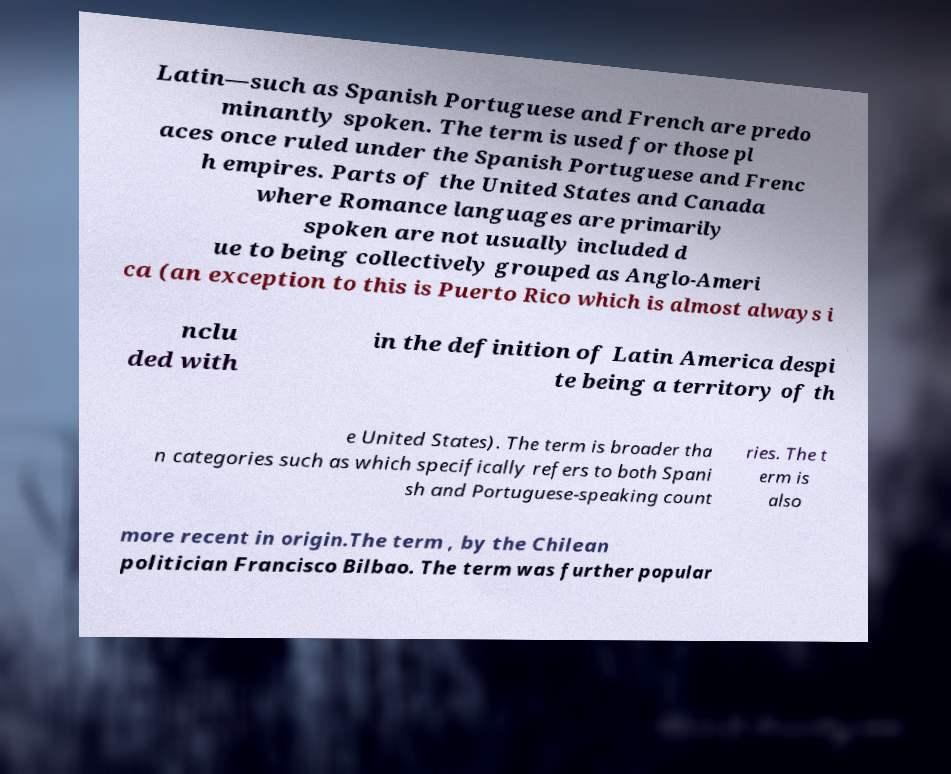There's text embedded in this image that I need extracted. Can you transcribe it verbatim? Latin—such as Spanish Portuguese and French are predo minantly spoken. The term is used for those pl aces once ruled under the Spanish Portuguese and Frenc h empires. Parts of the United States and Canada where Romance languages are primarily spoken are not usually included d ue to being collectively grouped as Anglo-Ameri ca (an exception to this is Puerto Rico which is almost always i nclu ded with in the definition of Latin America despi te being a territory of th e United States). The term is broader tha n categories such as which specifically refers to both Spani sh and Portuguese-speaking count ries. The t erm is also more recent in origin.The term , by the Chilean politician Francisco Bilbao. The term was further popular 